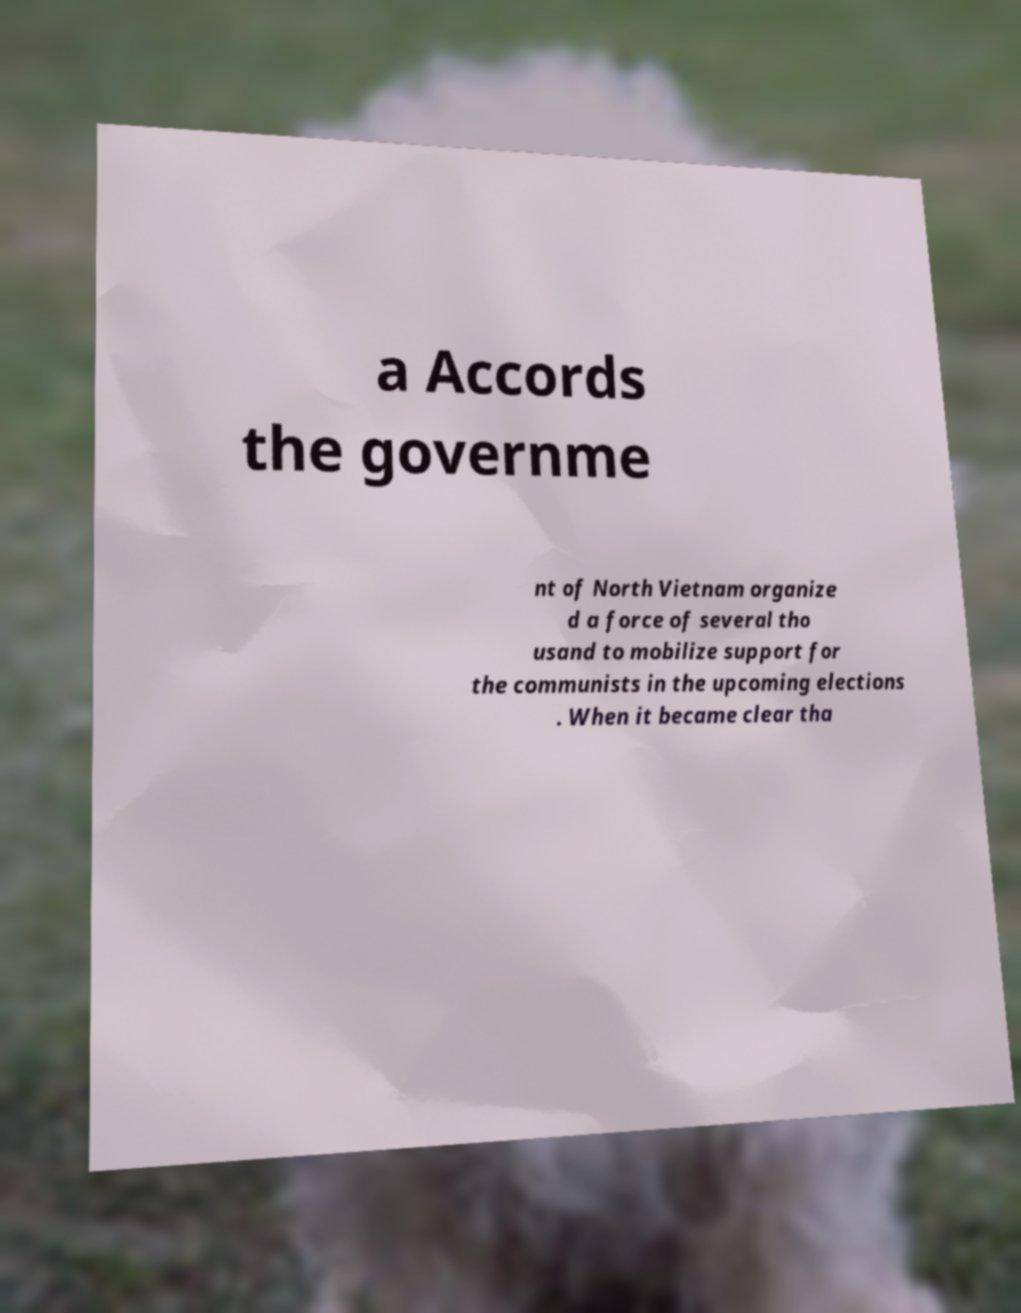Could you extract and type out the text from this image? a Accords the governme nt of North Vietnam organize d a force of several tho usand to mobilize support for the communists in the upcoming elections . When it became clear tha 